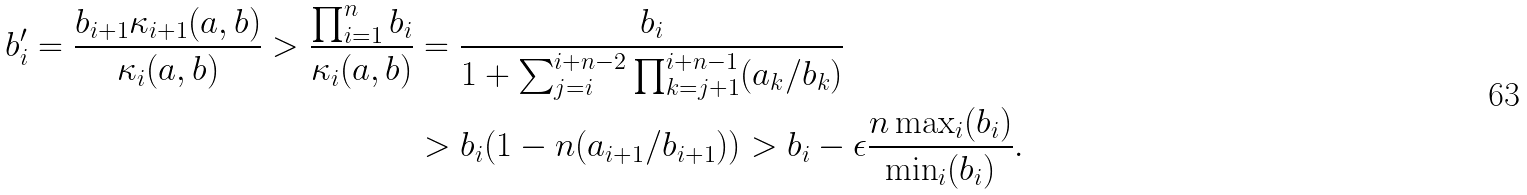Convert formula to latex. <formula><loc_0><loc_0><loc_500><loc_500>b ^ { \prime } _ { i } = \frac { b _ { i + 1 } \kappa _ { i + 1 } ( { a } , { b } ) } { \kappa _ { i } ( { a } , { b } ) } > \frac { \prod _ { i = 1 } ^ { n } b _ { i } } { \kappa _ { i } ( { a } , { b } ) } & = \frac { b _ { i } } { 1 + \sum _ { j = i } ^ { i + n - 2 } \prod _ { k = j + 1 } ^ { i + n - 1 } ( a _ { k } / b _ { k } ) } \\ & > b _ { i } ( 1 - n ( a _ { i + 1 } / b _ { i + 1 } ) ) > b _ { i } - \epsilon \frac { n \max _ { i } ( b _ { i } ) } { \min _ { i } ( b _ { i } ) } .</formula> 